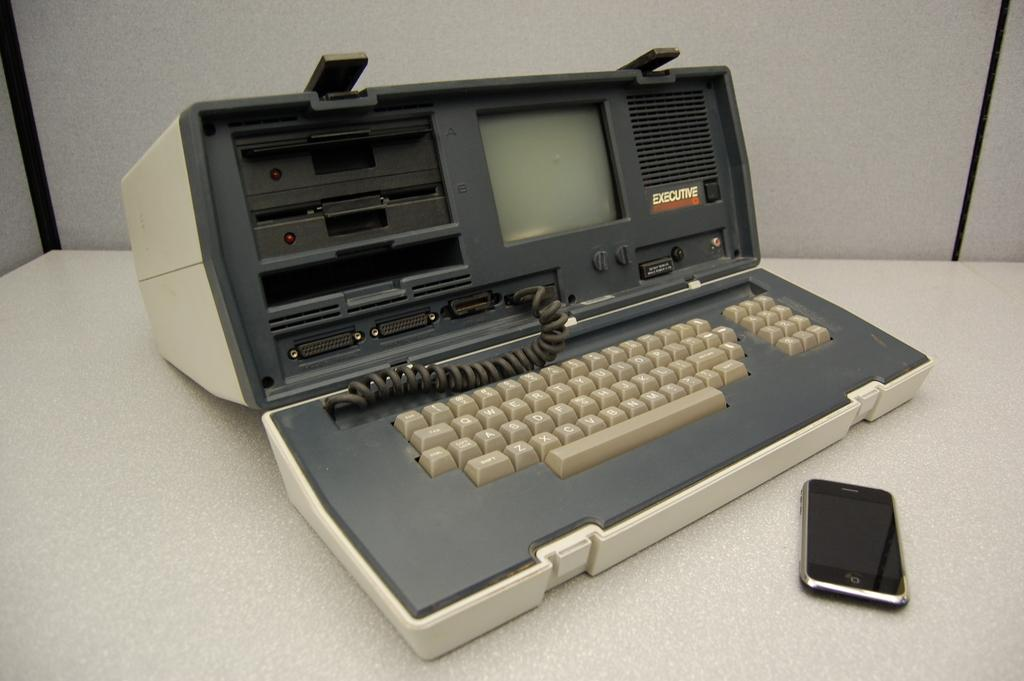What is the main object in the image? There is a machine in the image. What else can be seen in the image besides the machine? There is a mobile on an object in the image. What is behind the machine in the image? There is a wall behind the machine in the image. How many pets can be seen playing with a hole in the image? There are no pets or holes present in the image. 